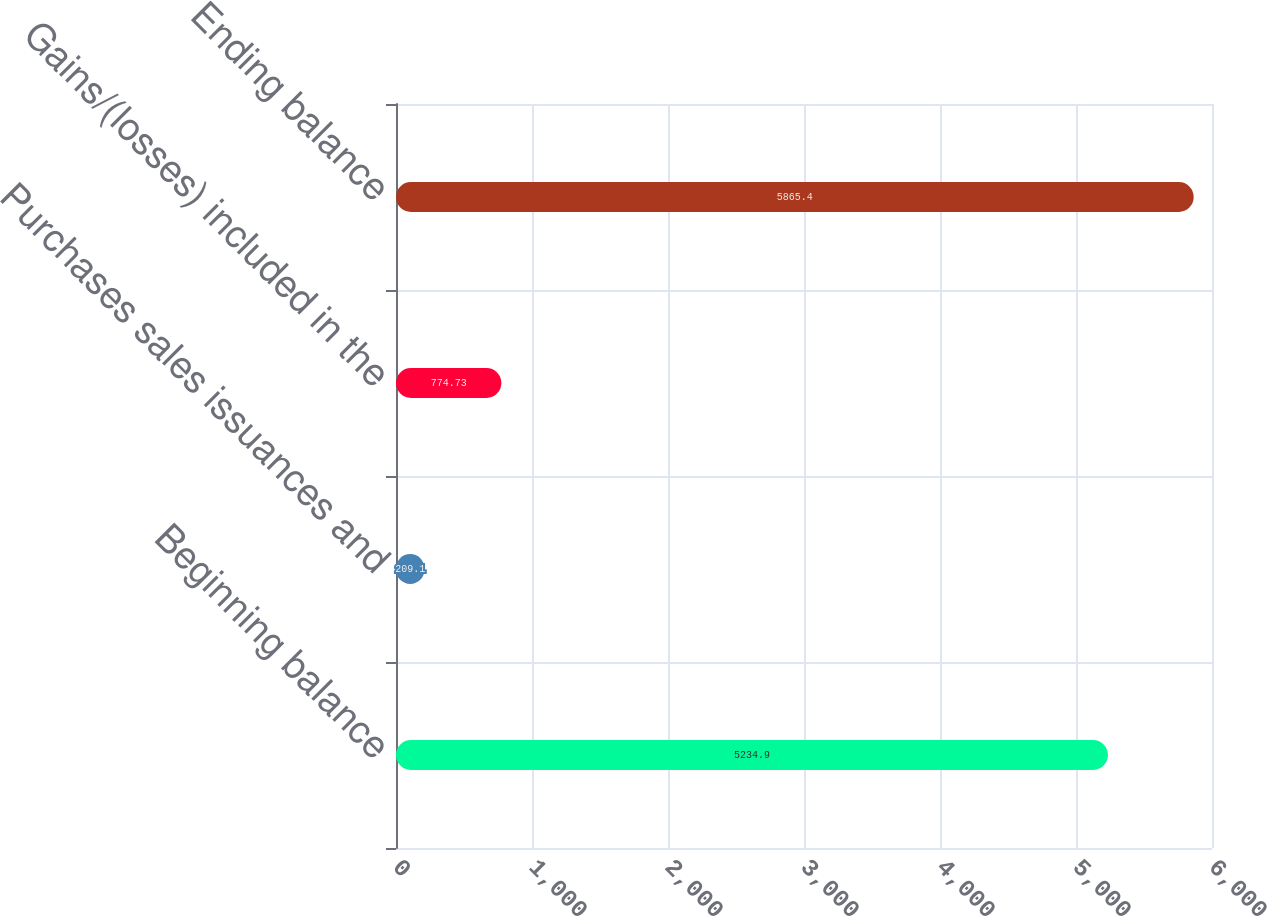Convert chart. <chart><loc_0><loc_0><loc_500><loc_500><bar_chart><fcel>Beginning balance<fcel>Purchases sales issuances and<fcel>Gains/(losses) included in the<fcel>Ending balance<nl><fcel>5234.9<fcel>209.1<fcel>774.73<fcel>5865.4<nl></chart> 